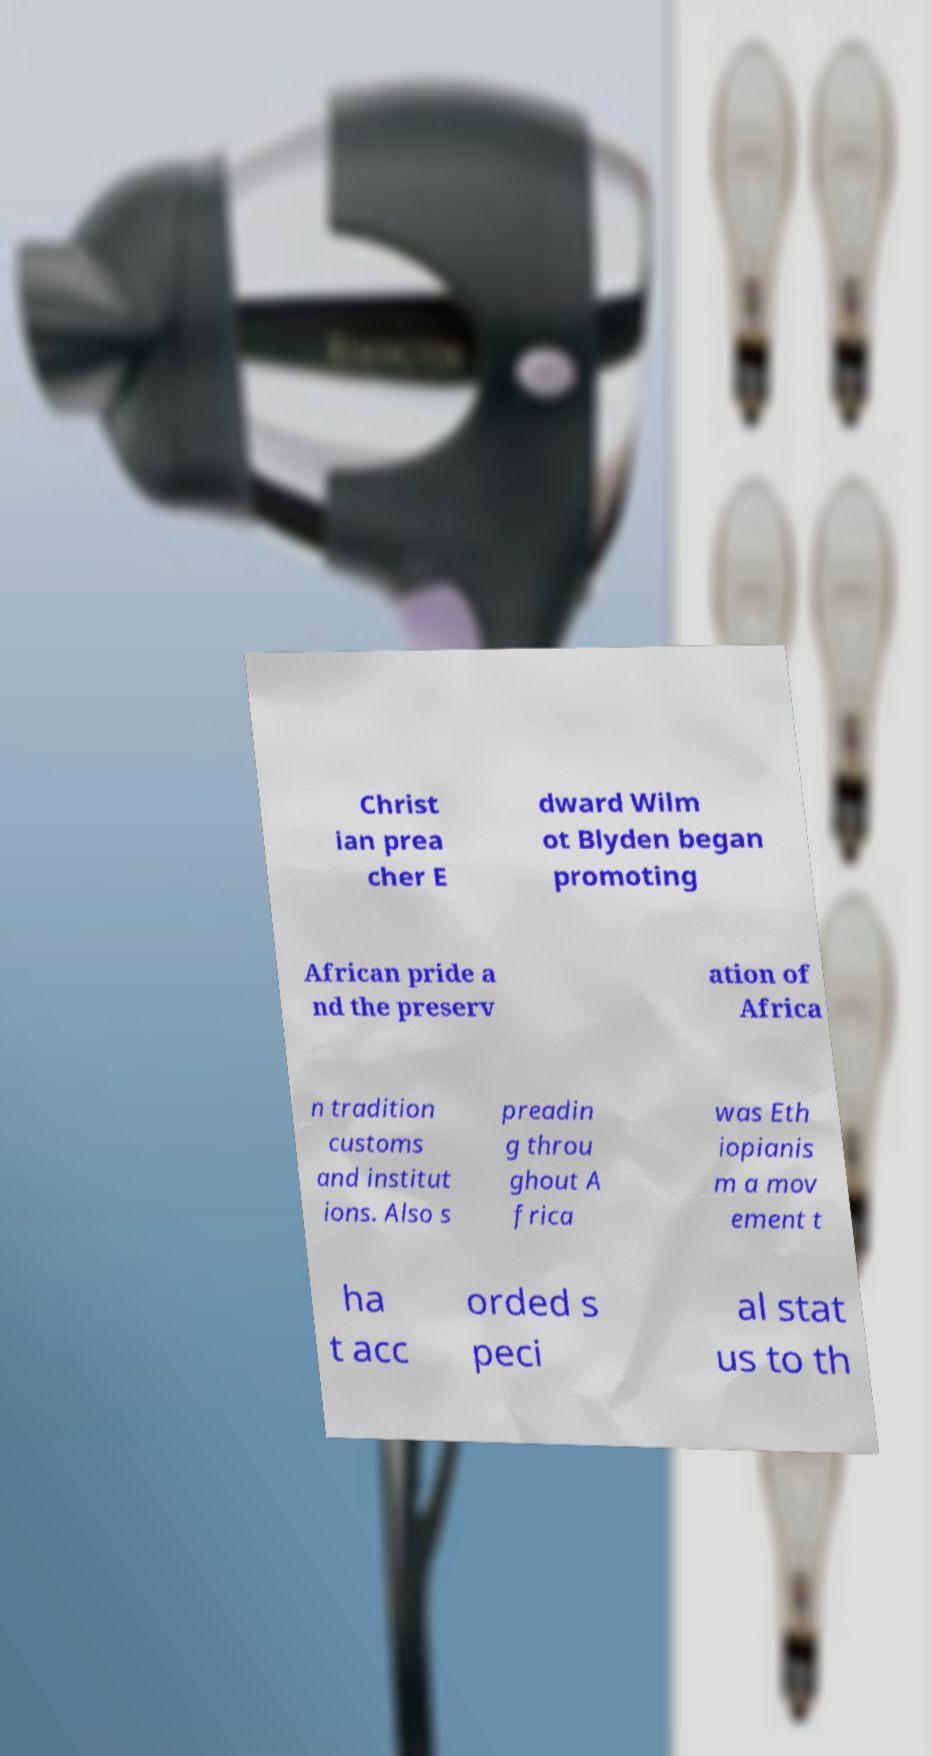Please identify and transcribe the text found in this image. Christ ian prea cher E dward Wilm ot Blyden began promoting African pride a nd the preserv ation of Africa n tradition customs and institut ions. Also s preadin g throu ghout A frica was Eth iopianis m a mov ement t ha t acc orded s peci al stat us to th 